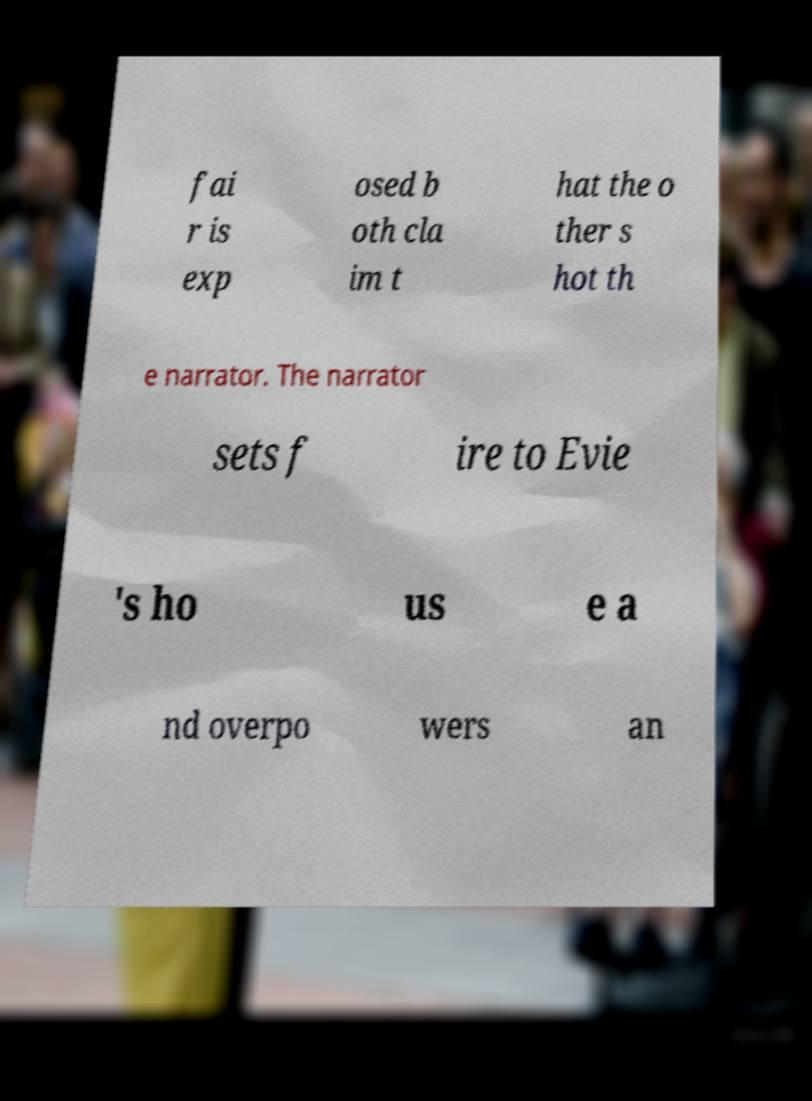I need the written content from this picture converted into text. Can you do that? fai r is exp osed b oth cla im t hat the o ther s hot th e narrator. The narrator sets f ire to Evie 's ho us e a nd overpo wers an 